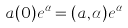<formula> <loc_0><loc_0><loc_500><loc_500>a ( 0 ) e ^ { \alpha } = ( a , \alpha ) e ^ { \alpha }</formula> 